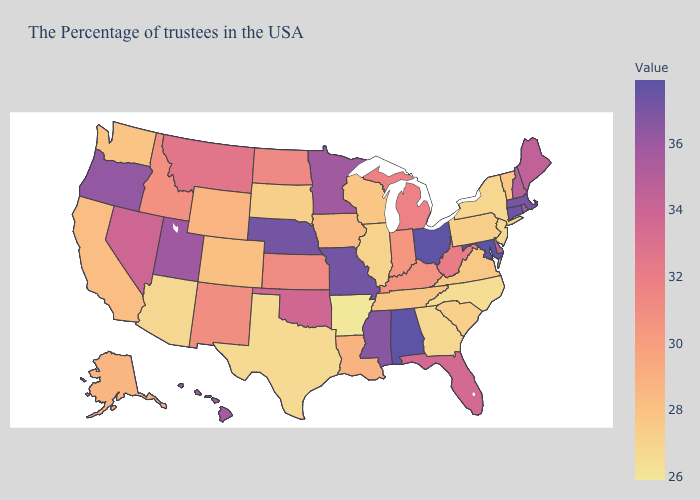Does North Dakota have a lower value than Nevada?
Write a very short answer. Yes. Does Arkansas have the lowest value in the USA?
Short answer required. Yes. Does Ohio have the highest value in the MidWest?
Keep it brief. Yes. Among the states that border Vermont , does New Hampshire have the highest value?
Answer briefly. No. Which states have the lowest value in the MidWest?
Give a very brief answer. Illinois. Which states have the lowest value in the USA?
Be succinct. Arkansas. Does Maryland have the highest value in the South?
Quick response, please. Yes. 